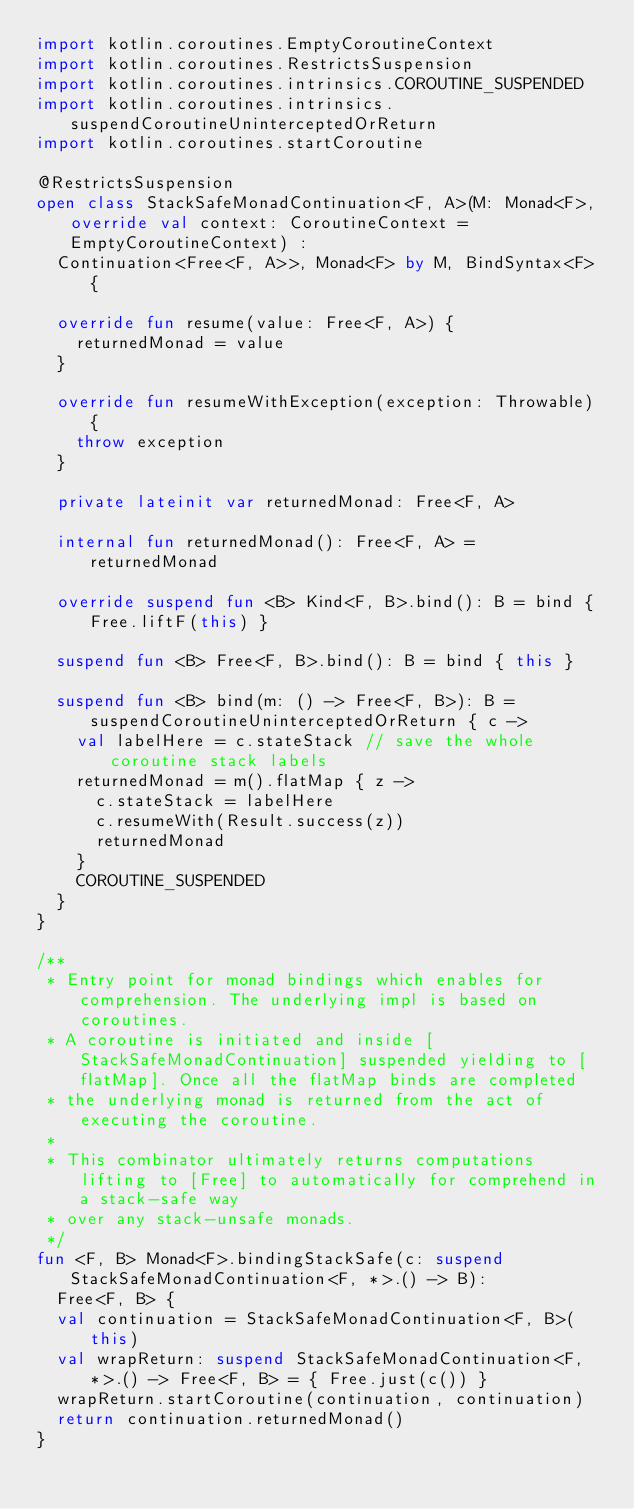<code> <loc_0><loc_0><loc_500><loc_500><_Kotlin_>import kotlin.coroutines.EmptyCoroutineContext
import kotlin.coroutines.RestrictsSuspension
import kotlin.coroutines.intrinsics.COROUTINE_SUSPENDED
import kotlin.coroutines.intrinsics.suspendCoroutineUninterceptedOrReturn
import kotlin.coroutines.startCoroutine

@RestrictsSuspension
open class StackSafeMonadContinuation<F, A>(M: Monad<F>, override val context: CoroutineContext = EmptyCoroutineContext) :
  Continuation<Free<F, A>>, Monad<F> by M, BindSyntax<F> {

  override fun resume(value: Free<F, A>) {
    returnedMonad = value
  }

  override fun resumeWithException(exception: Throwable) {
    throw exception
  }

  private lateinit var returnedMonad: Free<F, A>

  internal fun returnedMonad(): Free<F, A> = returnedMonad

  override suspend fun <B> Kind<F, B>.bind(): B = bind { Free.liftF(this) }

  suspend fun <B> Free<F, B>.bind(): B = bind { this }

  suspend fun <B> bind(m: () -> Free<F, B>): B = suspendCoroutineUninterceptedOrReturn { c ->
    val labelHere = c.stateStack // save the whole coroutine stack labels
    returnedMonad = m().flatMap { z ->
      c.stateStack = labelHere
      c.resumeWith(Result.success(z))
      returnedMonad
    }
    COROUTINE_SUSPENDED
  }
}

/**
 * Entry point for monad bindings which enables for comprehension. The underlying impl is based on coroutines.
 * A coroutine is initiated and inside [StackSafeMonadContinuation] suspended yielding to [flatMap]. Once all the flatMap binds are completed
 * the underlying monad is returned from the act of executing the coroutine.
 *
 * This combinator ultimately returns computations lifting to [Free] to automatically for comprehend in a stack-safe way
 * over any stack-unsafe monads.
 */
fun <F, B> Monad<F>.bindingStackSafe(c: suspend StackSafeMonadContinuation<F, *>.() -> B):
  Free<F, B> {
  val continuation = StackSafeMonadContinuation<F, B>(this)
  val wrapReturn: suspend StackSafeMonadContinuation<F, *>.() -> Free<F, B> = { Free.just(c()) }
  wrapReturn.startCoroutine(continuation, continuation)
  return continuation.returnedMonad()
}
</code> 